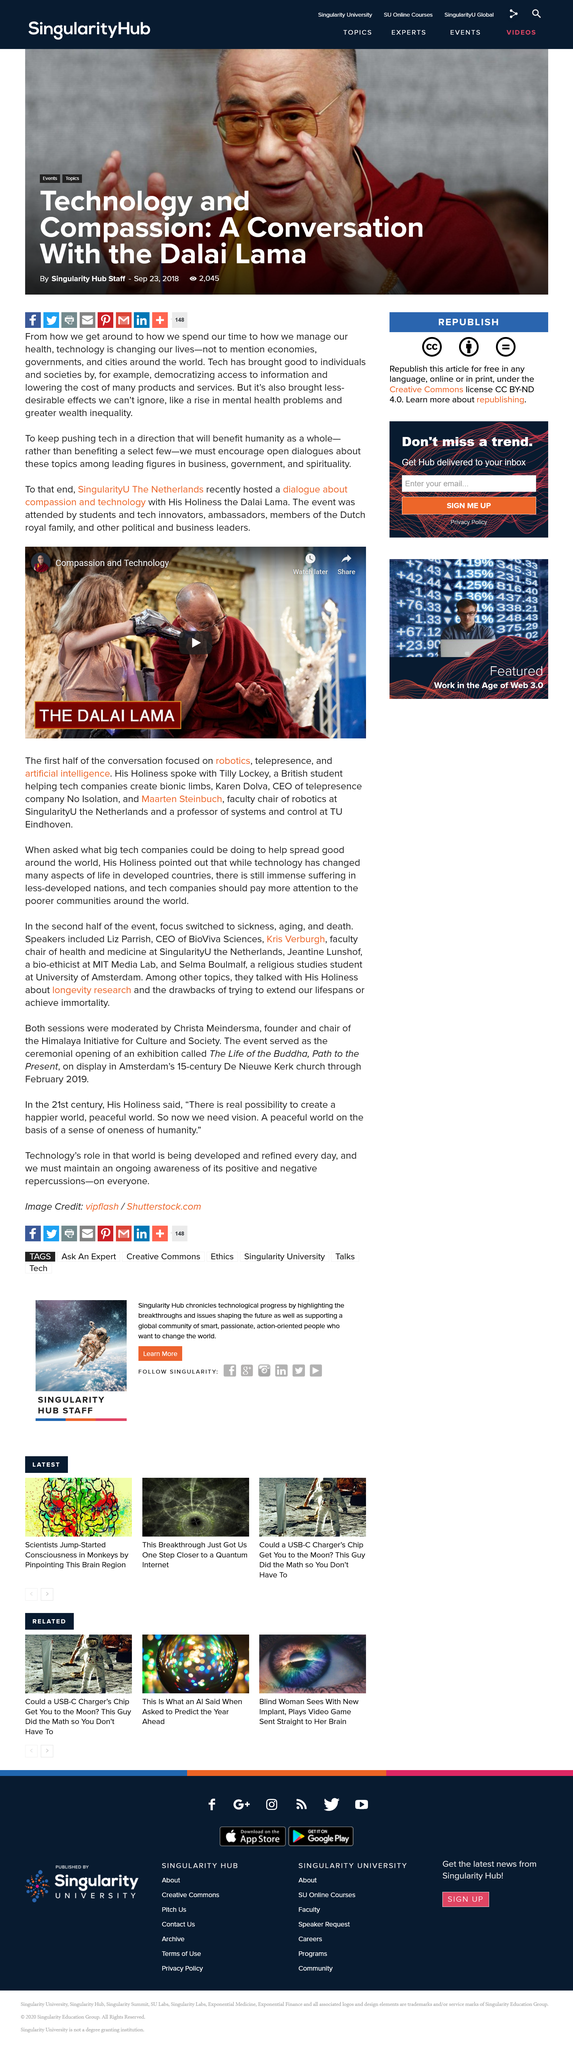Point out several critical features in this image. The Dalai Lama is depicted in the video. The Dutch royal family attended the event with the Dalai Lama. The dialogue took place in the Netherlands. 